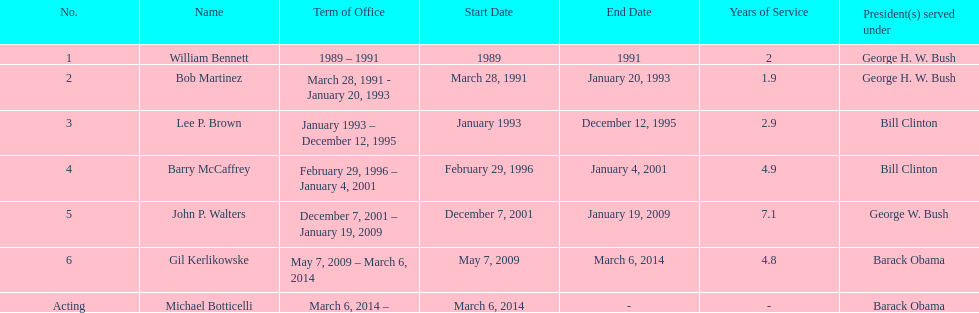When did john p. walters end his term? January 19, 2009. 